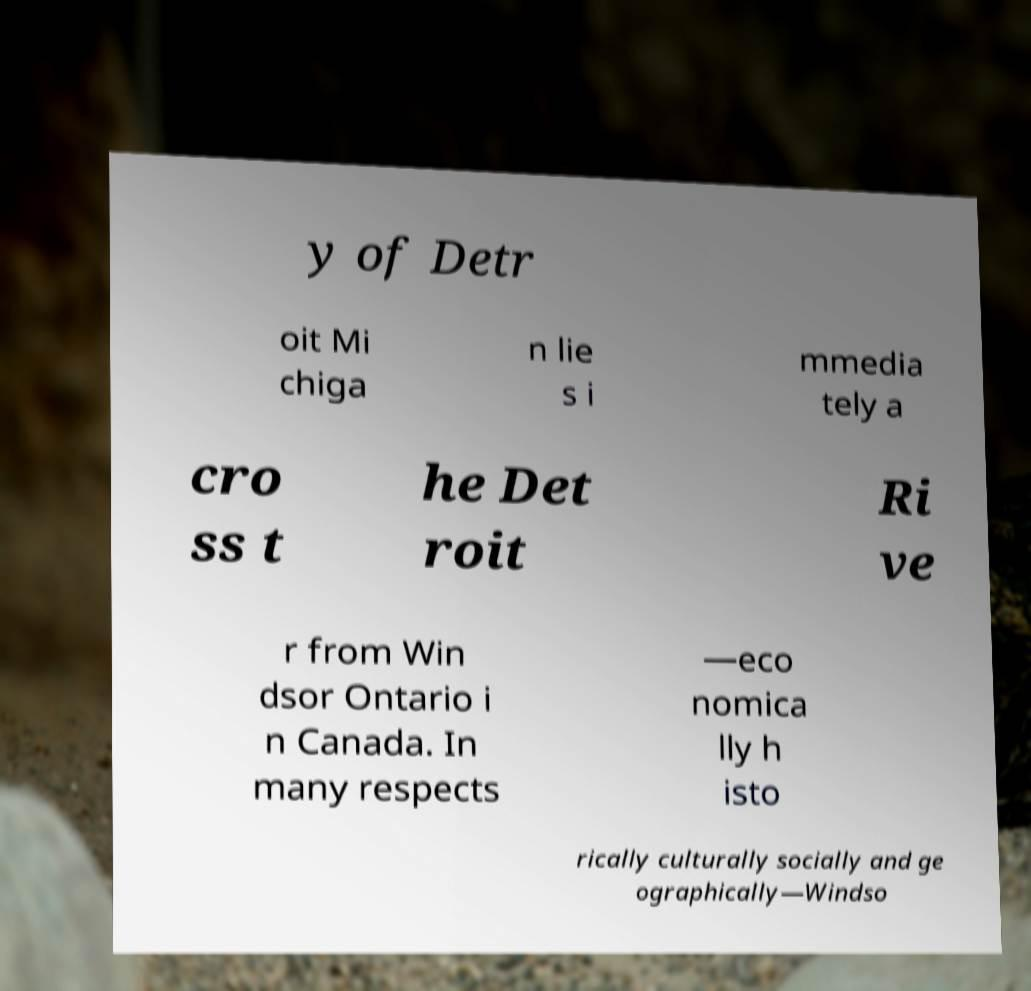For documentation purposes, I need the text within this image transcribed. Could you provide that? y of Detr oit Mi chiga n lie s i mmedia tely a cro ss t he Det roit Ri ve r from Win dsor Ontario i n Canada. In many respects —eco nomica lly h isto rically culturally socially and ge ographically—Windso 